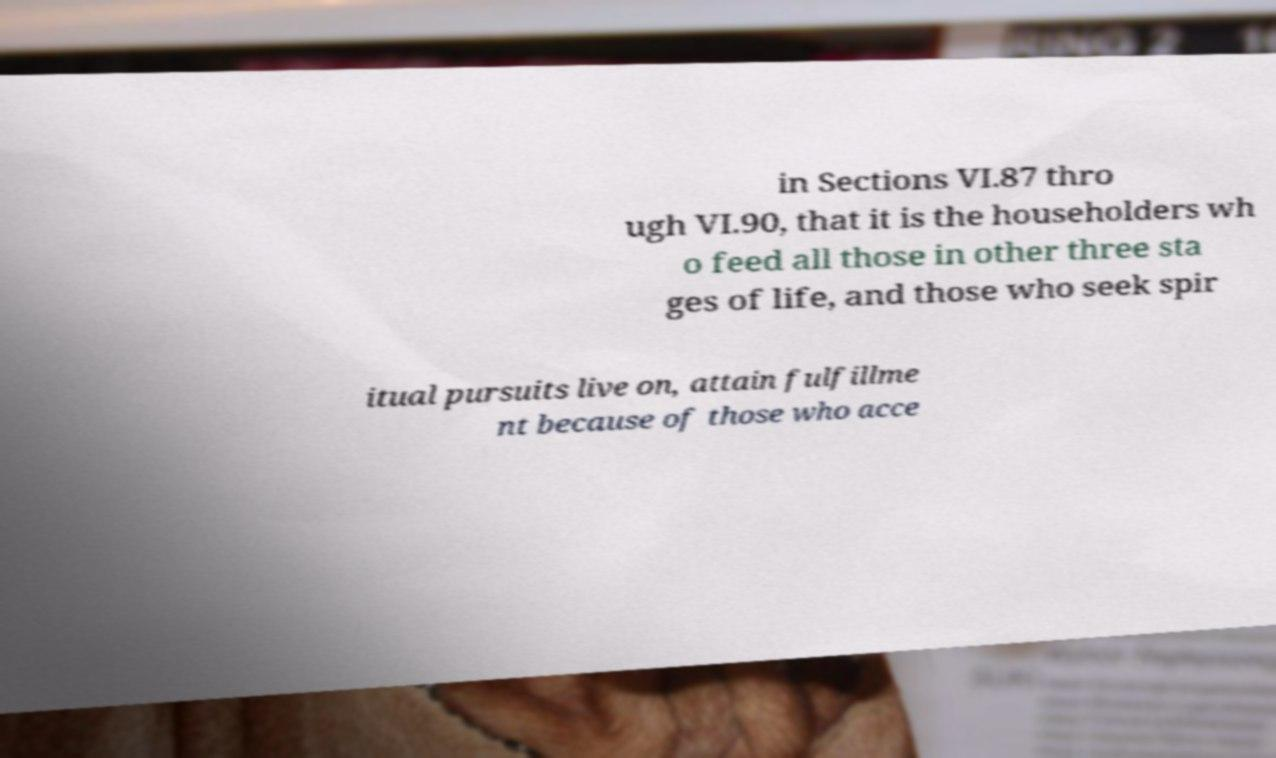I need the written content from this picture converted into text. Can you do that? in Sections VI.87 thro ugh VI.90, that it is the householders wh o feed all those in other three sta ges of life, and those who seek spir itual pursuits live on, attain fulfillme nt because of those who acce 